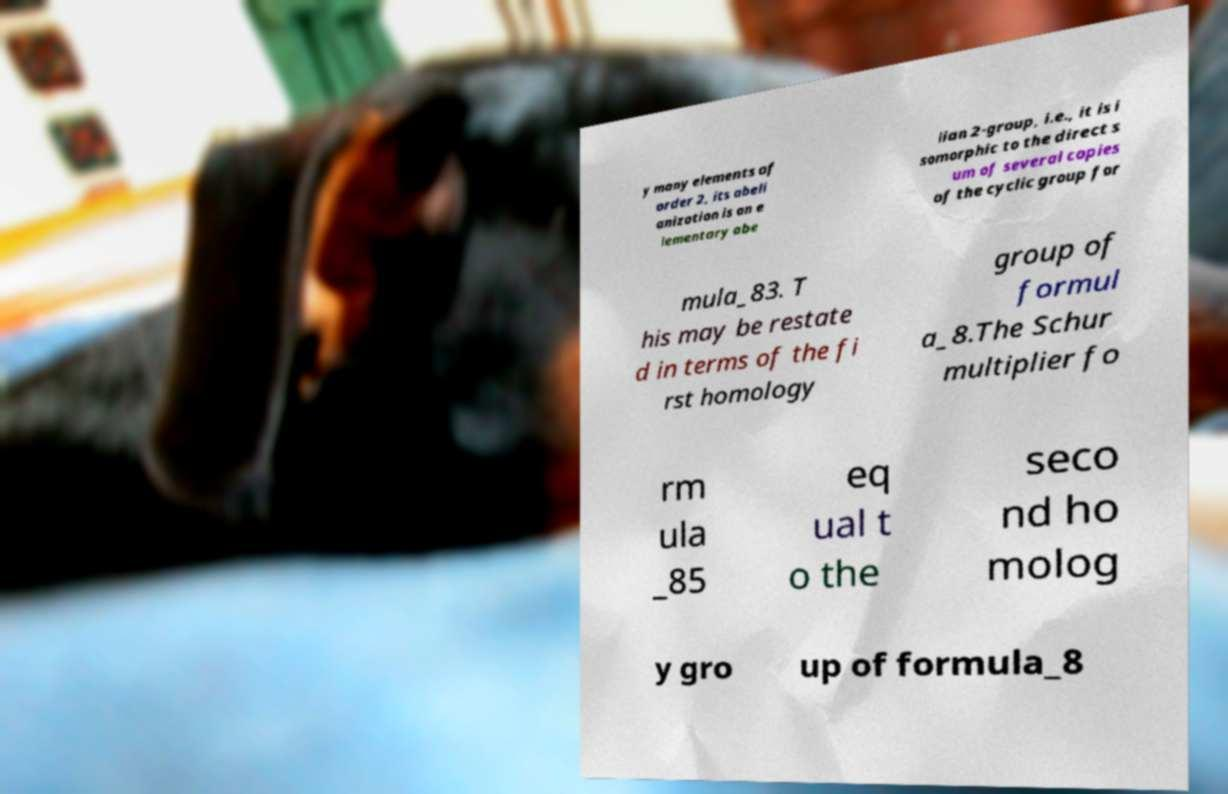For documentation purposes, I need the text within this image transcribed. Could you provide that? y many elements of order 2, its abeli anization is an e lementary abe lian 2-group, i.e., it is i somorphic to the direct s um of several copies of the cyclic group for mula_83. T his may be restate d in terms of the fi rst homology group of formul a_8.The Schur multiplier fo rm ula _85 eq ual t o the seco nd ho molog y gro up of formula_8 